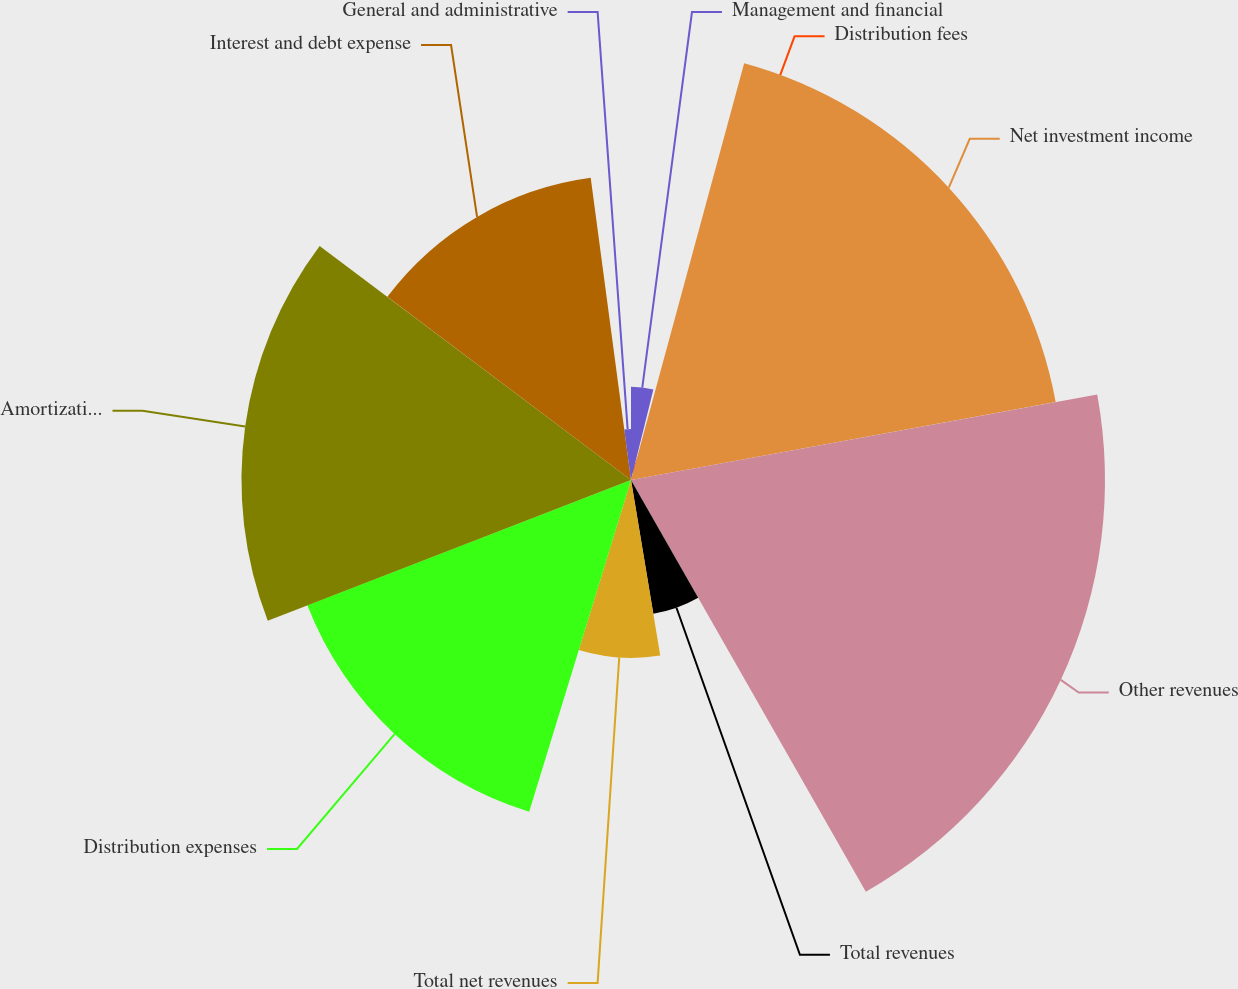Convert chart. <chart><loc_0><loc_0><loc_500><loc_500><pie_chart><fcel>Management and financial<fcel>Distribution fees<fcel>Net investment income<fcel>Other revenues<fcel>Total revenues<fcel>Total net revenues<fcel>Distribution expenses<fcel>Amortization of deferred<fcel>Interest and debt expense<fcel>General and administrative<nl><fcel>3.86%<fcel>0.36%<fcel>17.89%<fcel>19.64%<fcel>5.62%<fcel>7.37%<fcel>14.38%<fcel>16.14%<fcel>12.63%<fcel>2.11%<nl></chart> 